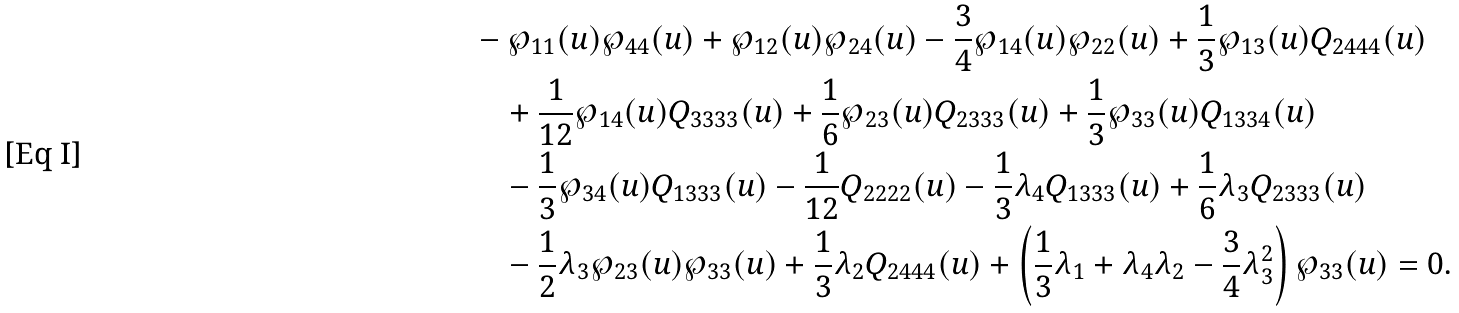<formula> <loc_0><loc_0><loc_500><loc_500>& - \wp _ { 1 1 } ( u ) \wp _ { 4 4 } ( u ) + \wp _ { 1 2 } ( u ) \wp _ { 2 4 } ( u ) - \frac { 3 } { 4 } \wp _ { 1 4 } ( u ) \wp _ { 2 2 } ( u ) + \frac { 1 } { 3 } \wp _ { 1 3 } ( u ) Q _ { 2 4 4 4 } ( u ) \\ & \quad + \frac { 1 } { 1 2 } \wp _ { 1 4 } ( u ) Q _ { 3 3 3 3 } ( u ) + \frac { 1 } { 6 } \wp _ { 2 3 } ( u ) Q _ { 2 3 3 3 } ( u ) + \frac { 1 } { 3 } \wp _ { 3 3 } ( u ) Q _ { 1 3 3 4 } ( u ) \\ & \quad - \frac { 1 } { 3 } \wp _ { 3 4 } ( u ) Q _ { 1 3 3 3 } ( u ) - \frac { 1 } { 1 2 } Q _ { 2 2 2 2 } ( u ) - \frac { 1 } { 3 } \lambda _ { 4 } Q _ { 1 3 3 3 } ( u ) + \frac { 1 } { 6 } \lambda _ { 3 } Q _ { 2 3 3 3 } ( u ) \\ & \quad - \frac { 1 } { 2 } \lambda _ { 3 } \wp _ { 2 3 } ( u ) \wp _ { 3 3 } ( u ) + \frac { 1 } { 3 } \lambda _ { 2 } Q _ { 2 4 4 4 } ( u ) + \left ( \frac { 1 } { 3 } \lambda _ { 1 } + \lambda _ { 4 } \lambda _ { 2 } - \frac { 3 } { 4 } \lambda _ { 3 } ^ { 2 } \right ) \wp _ { 3 3 } ( u ) = 0 .</formula> 